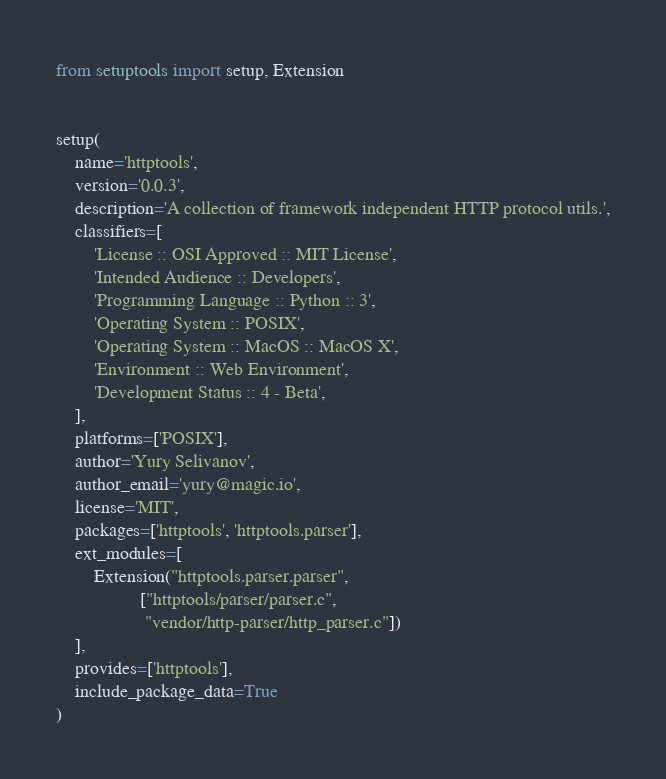Convert code to text. <code><loc_0><loc_0><loc_500><loc_500><_Python_>from setuptools import setup, Extension


setup(
    name='httptools',
    version='0.0.3',
    description='A collection of framework independent HTTP protocol utils.',
    classifiers=[
        'License :: OSI Approved :: MIT License',
        'Intended Audience :: Developers',
        'Programming Language :: Python :: 3',
        'Operating System :: POSIX',
        'Operating System :: MacOS :: MacOS X',
        'Environment :: Web Environment',
        'Development Status :: 4 - Beta',
    ],
    platforms=['POSIX'],
    author='Yury Selivanov',
    author_email='yury@magic.io',
    license='MIT',
    packages=['httptools', 'httptools.parser'],
    ext_modules=[
        Extension("httptools.parser.parser",
                  ["httptools/parser/parser.c",
                   "vendor/http-parser/http_parser.c"])
    ],
    provides=['httptools'],
    include_package_data=True
)
</code> 